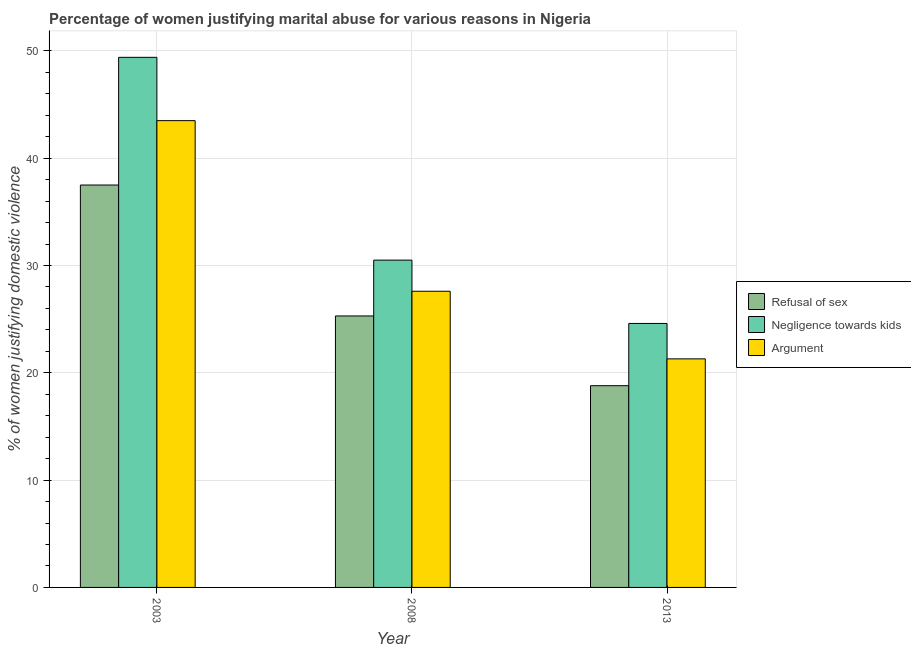How many different coloured bars are there?
Provide a succinct answer. 3. How many bars are there on the 2nd tick from the left?
Ensure brevity in your answer.  3. How many bars are there on the 2nd tick from the right?
Provide a short and direct response. 3. What is the label of the 3rd group of bars from the left?
Provide a short and direct response. 2013. What is the percentage of women justifying domestic violence due to arguments in 2013?
Give a very brief answer. 21.3. Across all years, what is the maximum percentage of women justifying domestic violence due to arguments?
Make the answer very short. 43.5. Across all years, what is the minimum percentage of women justifying domestic violence due to refusal of sex?
Make the answer very short. 18.8. In which year was the percentage of women justifying domestic violence due to negligence towards kids maximum?
Make the answer very short. 2003. In which year was the percentage of women justifying domestic violence due to negligence towards kids minimum?
Your answer should be compact. 2013. What is the total percentage of women justifying domestic violence due to refusal of sex in the graph?
Your response must be concise. 81.6. What is the difference between the percentage of women justifying domestic violence due to negligence towards kids in 2003 and that in 2013?
Make the answer very short. 24.8. What is the difference between the percentage of women justifying domestic violence due to arguments in 2003 and the percentage of women justifying domestic violence due to negligence towards kids in 2008?
Keep it short and to the point. 15.9. What is the average percentage of women justifying domestic violence due to refusal of sex per year?
Your response must be concise. 27.2. In the year 2013, what is the difference between the percentage of women justifying domestic violence due to negligence towards kids and percentage of women justifying domestic violence due to refusal of sex?
Provide a short and direct response. 0. What is the ratio of the percentage of women justifying domestic violence due to negligence towards kids in 2003 to that in 2013?
Your answer should be compact. 2.01. Is the difference between the percentage of women justifying domestic violence due to refusal of sex in 2003 and 2013 greater than the difference between the percentage of women justifying domestic violence due to negligence towards kids in 2003 and 2013?
Provide a succinct answer. No. In how many years, is the percentage of women justifying domestic violence due to negligence towards kids greater than the average percentage of women justifying domestic violence due to negligence towards kids taken over all years?
Your answer should be compact. 1. Is the sum of the percentage of women justifying domestic violence due to negligence towards kids in 2008 and 2013 greater than the maximum percentage of women justifying domestic violence due to arguments across all years?
Provide a short and direct response. Yes. What does the 2nd bar from the left in 2008 represents?
Provide a short and direct response. Negligence towards kids. What does the 3rd bar from the right in 2013 represents?
Provide a succinct answer. Refusal of sex. What is the difference between two consecutive major ticks on the Y-axis?
Give a very brief answer. 10. Does the graph contain grids?
Make the answer very short. Yes. What is the title of the graph?
Provide a succinct answer. Percentage of women justifying marital abuse for various reasons in Nigeria. What is the label or title of the Y-axis?
Ensure brevity in your answer.  % of women justifying domestic violence. What is the % of women justifying domestic violence of Refusal of sex in 2003?
Your response must be concise. 37.5. What is the % of women justifying domestic violence in Negligence towards kids in 2003?
Your answer should be very brief. 49.4. What is the % of women justifying domestic violence of Argument in 2003?
Give a very brief answer. 43.5. What is the % of women justifying domestic violence in Refusal of sex in 2008?
Make the answer very short. 25.3. What is the % of women justifying domestic violence of Negligence towards kids in 2008?
Ensure brevity in your answer.  30.5. What is the % of women justifying domestic violence in Argument in 2008?
Offer a very short reply. 27.6. What is the % of women justifying domestic violence of Refusal of sex in 2013?
Offer a very short reply. 18.8. What is the % of women justifying domestic violence of Negligence towards kids in 2013?
Give a very brief answer. 24.6. What is the % of women justifying domestic violence in Argument in 2013?
Ensure brevity in your answer.  21.3. Across all years, what is the maximum % of women justifying domestic violence in Refusal of sex?
Your answer should be very brief. 37.5. Across all years, what is the maximum % of women justifying domestic violence in Negligence towards kids?
Provide a succinct answer. 49.4. Across all years, what is the maximum % of women justifying domestic violence of Argument?
Offer a terse response. 43.5. Across all years, what is the minimum % of women justifying domestic violence of Negligence towards kids?
Make the answer very short. 24.6. Across all years, what is the minimum % of women justifying domestic violence in Argument?
Offer a very short reply. 21.3. What is the total % of women justifying domestic violence of Refusal of sex in the graph?
Keep it short and to the point. 81.6. What is the total % of women justifying domestic violence of Negligence towards kids in the graph?
Offer a very short reply. 104.5. What is the total % of women justifying domestic violence of Argument in the graph?
Give a very brief answer. 92.4. What is the difference between the % of women justifying domestic violence in Negligence towards kids in 2003 and that in 2008?
Your answer should be very brief. 18.9. What is the difference between the % of women justifying domestic violence in Refusal of sex in 2003 and that in 2013?
Your answer should be compact. 18.7. What is the difference between the % of women justifying domestic violence of Negligence towards kids in 2003 and that in 2013?
Provide a succinct answer. 24.8. What is the difference between the % of women justifying domestic violence in Negligence towards kids in 2008 and that in 2013?
Make the answer very short. 5.9. What is the difference between the % of women justifying domestic violence of Refusal of sex in 2003 and the % of women justifying domestic violence of Negligence towards kids in 2008?
Make the answer very short. 7. What is the difference between the % of women justifying domestic violence of Negligence towards kids in 2003 and the % of women justifying domestic violence of Argument in 2008?
Your response must be concise. 21.8. What is the difference between the % of women justifying domestic violence of Refusal of sex in 2003 and the % of women justifying domestic violence of Negligence towards kids in 2013?
Offer a very short reply. 12.9. What is the difference between the % of women justifying domestic violence in Negligence towards kids in 2003 and the % of women justifying domestic violence in Argument in 2013?
Provide a short and direct response. 28.1. What is the difference between the % of women justifying domestic violence of Refusal of sex in 2008 and the % of women justifying domestic violence of Negligence towards kids in 2013?
Provide a succinct answer. 0.7. What is the difference between the % of women justifying domestic violence in Negligence towards kids in 2008 and the % of women justifying domestic violence in Argument in 2013?
Offer a very short reply. 9.2. What is the average % of women justifying domestic violence of Refusal of sex per year?
Offer a very short reply. 27.2. What is the average % of women justifying domestic violence of Negligence towards kids per year?
Provide a short and direct response. 34.83. What is the average % of women justifying domestic violence in Argument per year?
Provide a short and direct response. 30.8. In the year 2003, what is the difference between the % of women justifying domestic violence in Refusal of sex and % of women justifying domestic violence in Negligence towards kids?
Provide a short and direct response. -11.9. In the year 2008, what is the difference between the % of women justifying domestic violence of Negligence towards kids and % of women justifying domestic violence of Argument?
Provide a short and direct response. 2.9. In the year 2013, what is the difference between the % of women justifying domestic violence of Refusal of sex and % of women justifying domestic violence of Negligence towards kids?
Your answer should be very brief. -5.8. In the year 2013, what is the difference between the % of women justifying domestic violence of Negligence towards kids and % of women justifying domestic violence of Argument?
Your response must be concise. 3.3. What is the ratio of the % of women justifying domestic violence of Refusal of sex in 2003 to that in 2008?
Your response must be concise. 1.48. What is the ratio of the % of women justifying domestic violence of Negligence towards kids in 2003 to that in 2008?
Provide a succinct answer. 1.62. What is the ratio of the % of women justifying domestic violence of Argument in 2003 to that in 2008?
Give a very brief answer. 1.58. What is the ratio of the % of women justifying domestic violence of Refusal of sex in 2003 to that in 2013?
Provide a succinct answer. 1.99. What is the ratio of the % of women justifying domestic violence of Negligence towards kids in 2003 to that in 2013?
Your answer should be compact. 2.01. What is the ratio of the % of women justifying domestic violence of Argument in 2003 to that in 2013?
Offer a terse response. 2.04. What is the ratio of the % of women justifying domestic violence in Refusal of sex in 2008 to that in 2013?
Keep it short and to the point. 1.35. What is the ratio of the % of women justifying domestic violence in Negligence towards kids in 2008 to that in 2013?
Keep it short and to the point. 1.24. What is the ratio of the % of women justifying domestic violence of Argument in 2008 to that in 2013?
Make the answer very short. 1.3. What is the difference between the highest and the second highest % of women justifying domestic violence in Argument?
Ensure brevity in your answer.  15.9. What is the difference between the highest and the lowest % of women justifying domestic violence in Negligence towards kids?
Keep it short and to the point. 24.8. What is the difference between the highest and the lowest % of women justifying domestic violence of Argument?
Provide a short and direct response. 22.2. 